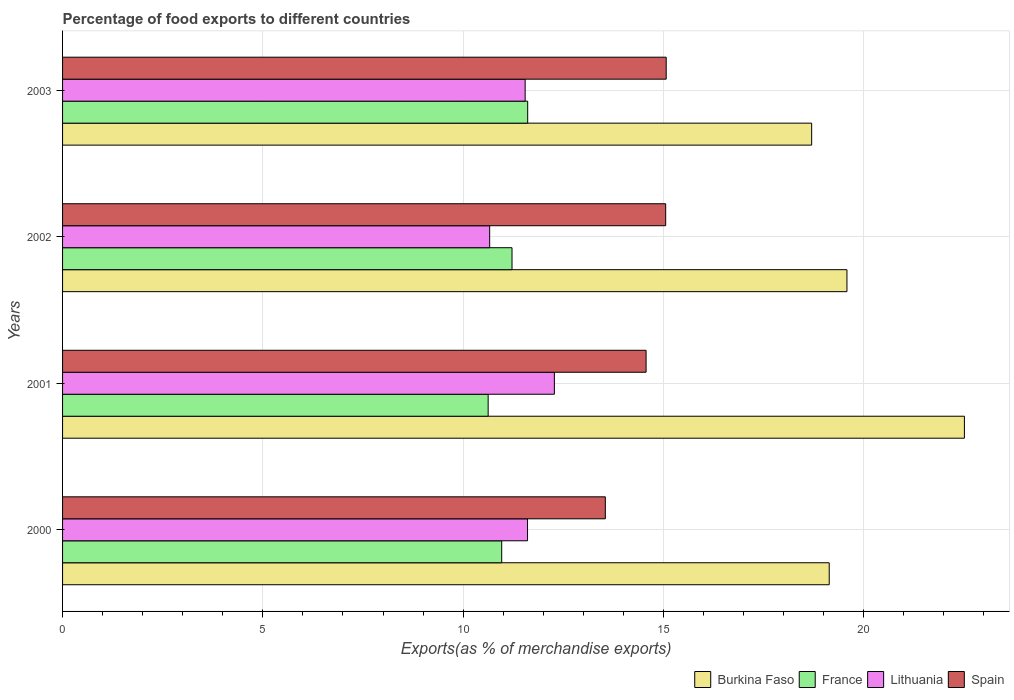How many groups of bars are there?
Offer a very short reply. 4. Are the number of bars on each tick of the Y-axis equal?
Offer a very short reply. Yes. How many bars are there on the 4th tick from the top?
Provide a succinct answer. 4. How many bars are there on the 4th tick from the bottom?
Provide a succinct answer. 4. What is the percentage of exports to different countries in Burkina Faso in 2002?
Offer a terse response. 19.58. Across all years, what is the maximum percentage of exports to different countries in Burkina Faso?
Make the answer very short. 22.51. Across all years, what is the minimum percentage of exports to different countries in Lithuania?
Provide a succinct answer. 10.66. What is the total percentage of exports to different countries in Lithuania in the graph?
Offer a very short reply. 46.09. What is the difference between the percentage of exports to different countries in France in 2000 and that in 2002?
Give a very brief answer. -0.26. What is the difference between the percentage of exports to different countries in Spain in 2000 and the percentage of exports to different countries in Burkina Faso in 2001?
Provide a short and direct response. -8.96. What is the average percentage of exports to different countries in Spain per year?
Provide a short and direct response. 14.56. In the year 2003, what is the difference between the percentage of exports to different countries in Lithuania and percentage of exports to different countries in Spain?
Offer a very short reply. -3.52. What is the ratio of the percentage of exports to different countries in Spain in 2002 to that in 2003?
Offer a terse response. 1. Is the percentage of exports to different countries in Lithuania in 2001 less than that in 2003?
Keep it short and to the point. No. What is the difference between the highest and the second highest percentage of exports to different countries in Lithuania?
Give a very brief answer. 0.67. What is the difference between the highest and the lowest percentage of exports to different countries in Burkina Faso?
Offer a terse response. 3.81. Is the sum of the percentage of exports to different countries in Burkina Faso in 2000 and 2001 greater than the maximum percentage of exports to different countries in Spain across all years?
Make the answer very short. Yes. Is it the case that in every year, the sum of the percentage of exports to different countries in Lithuania and percentage of exports to different countries in Spain is greater than the sum of percentage of exports to different countries in Burkina Faso and percentage of exports to different countries in France?
Make the answer very short. No. What does the 3rd bar from the bottom in 2002 represents?
Offer a very short reply. Lithuania. Is it the case that in every year, the sum of the percentage of exports to different countries in France and percentage of exports to different countries in Spain is greater than the percentage of exports to different countries in Burkina Faso?
Provide a succinct answer. Yes. Are all the bars in the graph horizontal?
Offer a very short reply. Yes. How many years are there in the graph?
Ensure brevity in your answer.  4. What is the difference between two consecutive major ticks on the X-axis?
Your answer should be compact. 5. Are the values on the major ticks of X-axis written in scientific E-notation?
Your answer should be compact. No. Does the graph contain any zero values?
Offer a terse response. No. Where does the legend appear in the graph?
Your response must be concise. Bottom right. What is the title of the graph?
Give a very brief answer. Percentage of food exports to different countries. Does "Eritrea" appear as one of the legend labels in the graph?
Ensure brevity in your answer.  No. What is the label or title of the X-axis?
Your answer should be very brief. Exports(as % of merchandise exports). What is the Exports(as % of merchandise exports) of Burkina Faso in 2000?
Keep it short and to the point. 19.14. What is the Exports(as % of merchandise exports) in France in 2000?
Give a very brief answer. 10.96. What is the Exports(as % of merchandise exports) in Lithuania in 2000?
Give a very brief answer. 11.61. What is the Exports(as % of merchandise exports) of Spain in 2000?
Offer a very short reply. 13.55. What is the Exports(as % of merchandise exports) in Burkina Faso in 2001?
Keep it short and to the point. 22.51. What is the Exports(as % of merchandise exports) of France in 2001?
Offer a terse response. 10.62. What is the Exports(as % of merchandise exports) in Lithuania in 2001?
Your response must be concise. 12.28. What is the Exports(as % of merchandise exports) of Spain in 2001?
Offer a terse response. 14.57. What is the Exports(as % of merchandise exports) in Burkina Faso in 2002?
Your response must be concise. 19.58. What is the Exports(as % of merchandise exports) of France in 2002?
Your answer should be very brief. 11.22. What is the Exports(as % of merchandise exports) in Lithuania in 2002?
Your answer should be very brief. 10.66. What is the Exports(as % of merchandise exports) of Spain in 2002?
Give a very brief answer. 15.06. What is the Exports(as % of merchandise exports) of Burkina Faso in 2003?
Make the answer very short. 18.7. What is the Exports(as % of merchandise exports) of France in 2003?
Offer a very short reply. 11.61. What is the Exports(as % of merchandise exports) in Lithuania in 2003?
Provide a short and direct response. 11.55. What is the Exports(as % of merchandise exports) in Spain in 2003?
Offer a very short reply. 15.07. Across all years, what is the maximum Exports(as % of merchandise exports) in Burkina Faso?
Your response must be concise. 22.51. Across all years, what is the maximum Exports(as % of merchandise exports) in France?
Ensure brevity in your answer.  11.61. Across all years, what is the maximum Exports(as % of merchandise exports) in Lithuania?
Your response must be concise. 12.28. Across all years, what is the maximum Exports(as % of merchandise exports) of Spain?
Provide a short and direct response. 15.07. Across all years, what is the minimum Exports(as % of merchandise exports) in Burkina Faso?
Offer a very short reply. 18.7. Across all years, what is the minimum Exports(as % of merchandise exports) of France?
Your response must be concise. 10.62. Across all years, what is the minimum Exports(as % of merchandise exports) of Lithuania?
Make the answer very short. 10.66. Across all years, what is the minimum Exports(as % of merchandise exports) in Spain?
Make the answer very short. 13.55. What is the total Exports(as % of merchandise exports) of Burkina Faso in the graph?
Your answer should be very brief. 79.93. What is the total Exports(as % of merchandise exports) in France in the graph?
Ensure brevity in your answer.  44.42. What is the total Exports(as % of merchandise exports) of Lithuania in the graph?
Give a very brief answer. 46.09. What is the total Exports(as % of merchandise exports) in Spain in the graph?
Your answer should be very brief. 58.24. What is the difference between the Exports(as % of merchandise exports) of Burkina Faso in 2000 and that in 2001?
Make the answer very short. -3.37. What is the difference between the Exports(as % of merchandise exports) in France in 2000 and that in 2001?
Provide a succinct answer. 0.34. What is the difference between the Exports(as % of merchandise exports) of Lithuania in 2000 and that in 2001?
Provide a short and direct response. -0.67. What is the difference between the Exports(as % of merchandise exports) in Spain in 2000 and that in 2001?
Give a very brief answer. -1.02. What is the difference between the Exports(as % of merchandise exports) of Burkina Faso in 2000 and that in 2002?
Provide a succinct answer. -0.44. What is the difference between the Exports(as % of merchandise exports) of France in 2000 and that in 2002?
Offer a very short reply. -0.26. What is the difference between the Exports(as % of merchandise exports) of Lithuania in 2000 and that in 2002?
Give a very brief answer. 0.95. What is the difference between the Exports(as % of merchandise exports) in Spain in 2000 and that in 2002?
Keep it short and to the point. -1.51. What is the difference between the Exports(as % of merchandise exports) in Burkina Faso in 2000 and that in 2003?
Keep it short and to the point. 0.44. What is the difference between the Exports(as % of merchandise exports) of France in 2000 and that in 2003?
Provide a succinct answer. -0.65. What is the difference between the Exports(as % of merchandise exports) in Lithuania in 2000 and that in 2003?
Your answer should be very brief. 0.06. What is the difference between the Exports(as % of merchandise exports) in Spain in 2000 and that in 2003?
Give a very brief answer. -1.52. What is the difference between the Exports(as % of merchandise exports) of Burkina Faso in 2001 and that in 2002?
Keep it short and to the point. 2.93. What is the difference between the Exports(as % of merchandise exports) of France in 2001 and that in 2002?
Your answer should be compact. -0.6. What is the difference between the Exports(as % of merchandise exports) of Lithuania in 2001 and that in 2002?
Your answer should be very brief. 1.62. What is the difference between the Exports(as % of merchandise exports) in Spain in 2001 and that in 2002?
Your answer should be compact. -0.49. What is the difference between the Exports(as % of merchandise exports) in Burkina Faso in 2001 and that in 2003?
Your response must be concise. 3.81. What is the difference between the Exports(as % of merchandise exports) in France in 2001 and that in 2003?
Offer a terse response. -0.99. What is the difference between the Exports(as % of merchandise exports) of Lithuania in 2001 and that in 2003?
Offer a very short reply. 0.73. What is the difference between the Exports(as % of merchandise exports) of Spain in 2001 and that in 2003?
Your answer should be very brief. -0.5. What is the difference between the Exports(as % of merchandise exports) in Burkina Faso in 2002 and that in 2003?
Offer a terse response. 0.88. What is the difference between the Exports(as % of merchandise exports) of France in 2002 and that in 2003?
Provide a succinct answer. -0.39. What is the difference between the Exports(as % of merchandise exports) in Lithuania in 2002 and that in 2003?
Keep it short and to the point. -0.89. What is the difference between the Exports(as % of merchandise exports) in Spain in 2002 and that in 2003?
Your response must be concise. -0.01. What is the difference between the Exports(as % of merchandise exports) of Burkina Faso in 2000 and the Exports(as % of merchandise exports) of France in 2001?
Provide a succinct answer. 8.51. What is the difference between the Exports(as % of merchandise exports) of Burkina Faso in 2000 and the Exports(as % of merchandise exports) of Lithuania in 2001?
Your answer should be compact. 6.86. What is the difference between the Exports(as % of merchandise exports) in Burkina Faso in 2000 and the Exports(as % of merchandise exports) in Spain in 2001?
Your answer should be compact. 4.57. What is the difference between the Exports(as % of merchandise exports) in France in 2000 and the Exports(as % of merchandise exports) in Lithuania in 2001?
Keep it short and to the point. -1.31. What is the difference between the Exports(as % of merchandise exports) in France in 2000 and the Exports(as % of merchandise exports) in Spain in 2001?
Your response must be concise. -3.6. What is the difference between the Exports(as % of merchandise exports) of Lithuania in 2000 and the Exports(as % of merchandise exports) of Spain in 2001?
Provide a succinct answer. -2.96. What is the difference between the Exports(as % of merchandise exports) of Burkina Faso in 2000 and the Exports(as % of merchandise exports) of France in 2002?
Keep it short and to the point. 7.92. What is the difference between the Exports(as % of merchandise exports) in Burkina Faso in 2000 and the Exports(as % of merchandise exports) in Lithuania in 2002?
Ensure brevity in your answer.  8.48. What is the difference between the Exports(as % of merchandise exports) in Burkina Faso in 2000 and the Exports(as % of merchandise exports) in Spain in 2002?
Your response must be concise. 4.08. What is the difference between the Exports(as % of merchandise exports) of France in 2000 and the Exports(as % of merchandise exports) of Lithuania in 2002?
Your answer should be compact. 0.3. What is the difference between the Exports(as % of merchandise exports) in France in 2000 and the Exports(as % of merchandise exports) in Spain in 2002?
Your answer should be very brief. -4.09. What is the difference between the Exports(as % of merchandise exports) in Lithuania in 2000 and the Exports(as % of merchandise exports) in Spain in 2002?
Provide a short and direct response. -3.45. What is the difference between the Exports(as % of merchandise exports) of Burkina Faso in 2000 and the Exports(as % of merchandise exports) of France in 2003?
Ensure brevity in your answer.  7.53. What is the difference between the Exports(as % of merchandise exports) in Burkina Faso in 2000 and the Exports(as % of merchandise exports) in Lithuania in 2003?
Ensure brevity in your answer.  7.59. What is the difference between the Exports(as % of merchandise exports) in Burkina Faso in 2000 and the Exports(as % of merchandise exports) in Spain in 2003?
Ensure brevity in your answer.  4.07. What is the difference between the Exports(as % of merchandise exports) in France in 2000 and the Exports(as % of merchandise exports) in Lithuania in 2003?
Provide a succinct answer. -0.59. What is the difference between the Exports(as % of merchandise exports) in France in 2000 and the Exports(as % of merchandise exports) in Spain in 2003?
Your response must be concise. -4.11. What is the difference between the Exports(as % of merchandise exports) in Lithuania in 2000 and the Exports(as % of merchandise exports) in Spain in 2003?
Your response must be concise. -3.46. What is the difference between the Exports(as % of merchandise exports) of Burkina Faso in 2001 and the Exports(as % of merchandise exports) of France in 2002?
Offer a terse response. 11.29. What is the difference between the Exports(as % of merchandise exports) in Burkina Faso in 2001 and the Exports(as % of merchandise exports) in Lithuania in 2002?
Offer a terse response. 11.85. What is the difference between the Exports(as % of merchandise exports) of Burkina Faso in 2001 and the Exports(as % of merchandise exports) of Spain in 2002?
Keep it short and to the point. 7.46. What is the difference between the Exports(as % of merchandise exports) in France in 2001 and the Exports(as % of merchandise exports) in Lithuania in 2002?
Offer a very short reply. -0.04. What is the difference between the Exports(as % of merchandise exports) in France in 2001 and the Exports(as % of merchandise exports) in Spain in 2002?
Ensure brevity in your answer.  -4.43. What is the difference between the Exports(as % of merchandise exports) of Lithuania in 2001 and the Exports(as % of merchandise exports) of Spain in 2002?
Offer a very short reply. -2.78. What is the difference between the Exports(as % of merchandise exports) in Burkina Faso in 2001 and the Exports(as % of merchandise exports) in France in 2003?
Provide a short and direct response. 10.9. What is the difference between the Exports(as % of merchandise exports) in Burkina Faso in 2001 and the Exports(as % of merchandise exports) in Lithuania in 2003?
Keep it short and to the point. 10.97. What is the difference between the Exports(as % of merchandise exports) in Burkina Faso in 2001 and the Exports(as % of merchandise exports) in Spain in 2003?
Keep it short and to the point. 7.44. What is the difference between the Exports(as % of merchandise exports) of France in 2001 and the Exports(as % of merchandise exports) of Lithuania in 2003?
Offer a very short reply. -0.92. What is the difference between the Exports(as % of merchandise exports) of France in 2001 and the Exports(as % of merchandise exports) of Spain in 2003?
Your answer should be compact. -4.44. What is the difference between the Exports(as % of merchandise exports) in Lithuania in 2001 and the Exports(as % of merchandise exports) in Spain in 2003?
Offer a terse response. -2.79. What is the difference between the Exports(as % of merchandise exports) of Burkina Faso in 2002 and the Exports(as % of merchandise exports) of France in 2003?
Provide a succinct answer. 7.97. What is the difference between the Exports(as % of merchandise exports) in Burkina Faso in 2002 and the Exports(as % of merchandise exports) in Lithuania in 2003?
Make the answer very short. 8.03. What is the difference between the Exports(as % of merchandise exports) in Burkina Faso in 2002 and the Exports(as % of merchandise exports) in Spain in 2003?
Your answer should be compact. 4.51. What is the difference between the Exports(as % of merchandise exports) in France in 2002 and the Exports(as % of merchandise exports) in Lithuania in 2003?
Offer a very short reply. -0.33. What is the difference between the Exports(as % of merchandise exports) of France in 2002 and the Exports(as % of merchandise exports) of Spain in 2003?
Your response must be concise. -3.85. What is the difference between the Exports(as % of merchandise exports) in Lithuania in 2002 and the Exports(as % of merchandise exports) in Spain in 2003?
Ensure brevity in your answer.  -4.41. What is the average Exports(as % of merchandise exports) in Burkina Faso per year?
Your answer should be very brief. 19.98. What is the average Exports(as % of merchandise exports) of France per year?
Offer a terse response. 11.1. What is the average Exports(as % of merchandise exports) in Lithuania per year?
Make the answer very short. 11.52. What is the average Exports(as % of merchandise exports) in Spain per year?
Your answer should be compact. 14.56. In the year 2000, what is the difference between the Exports(as % of merchandise exports) in Burkina Faso and Exports(as % of merchandise exports) in France?
Ensure brevity in your answer.  8.18. In the year 2000, what is the difference between the Exports(as % of merchandise exports) of Burkina Faso and Exports(as % of merchandise exports) of Lithuania?
Your answer should be very brief. 7.53. In the year 2000, what is the difference between the Exports(as % of merchandise exports) in Burkina Faso and Exports(as % of merchandise exports) in Spain?
Provide a short and direct response. 5.59. In the year 2000, what is the difference between the Exports(as % of merchandise exports) in France and Exports(as % of merchandise exports) in Lithuania?
Your answer should be compact. -0.64. In the year 2000, what is the difference between the Exports(as % of merchandise exports) of France and Exports(as % of merchandise exports) of Spain?
Your answer should be compact. -2.59. In the year 2000, what is the difference between the Exports(as % of merchandise exports) of Lithuania and Exports(as % of merchandise exports) of Spain?
Ensure brevity in your answer.  -1.94. In the year 2001, what is the difference between the Exports(as % of merchandise exports) in Burkina Faso and Exports(as % of merchandise exports) in France?
Ensure brevity in your answer.  11.89. In the year 2001, what is the difference between the Exports(as % of merchandise exports) in Burkina Faso and Exports(as % of merchandise exports) in Lithuania?
Keep it short and to the point. 10.24. In the year 2001, what is the difference between the Exports(as % of merchandise exports) of Burkina Faso and Exports(as % of merchandise exports) of Spain?
Your answer should be very brief. 7.95. In the year 2001, what is the difference between the Exports(as % of merchandise exports) of France and Exports(as % of merchandise exports) of Lithuania?
Offer a terse response. -1.65. In the year 2001, what is the difference between the Exports(as % of merchandise exports) of France and Exports(as % of merchandise exports) of Spain?
Your answer should be compact. -3.94. In the year 2001, what is the difference between the Exports(as % of merchandise exports) of Lithuania and Exports(as % of merchandise exports) of Spain?
Your answer should be compact. -2.29. In the year 2002, what is the difference between the Exports(as % of merchandise exports) in Burkina Faso and Exports(as % of merchandise exports) in France?
Provide a short and direct response. 8.36. In the year 2002, what is the difference between the Exports(as % of merchandise exports) of Burkina Faso and Exports(as % of merchandise exports) of Lithuania?
Your answer should be compact. 8.92. In the year 2002, what is the difference between the Exports(as % of merchandise exports) of Burkina Faso and Exports(as % of merchandise exports) of Spain?
Provide a short and direct response. 4.53. In the year 2002, what is the difference between the Exports(as % of merchandise exports) in France and Exports(as % of merchandise exports) in Lithuania?
Offer a very short reply. 0.56. In the year 2002, what is the difference between the Exports(as % of merchandise exports) of France and Exports(as % of merchandise exports) of Spain?
Your answer should be very brief. -3.84. In the year 2002, what is the difference between the Exports(as % of merchandise exports) of Lithuania and Exports(as % of merchandise exports) of Spain?
Keep it short and to the point. -4.39. In the year 2003, what is the difference between the Exports(as % of merchandise exports) in Burkina Faso and Exports(as % of merchandise exports) in France?
Make the answer very short. 7.09. In the year 2003, what is the difference between the Exports(as % of merchandise exports) in Burkina Faso and Exports(as % of merchandise exports) in Lithuania?
Keep it short and to the point. 7.15. In the year 2003, what is the difference between the Exports(as % of merchandise exports) of Burkina Faso and Exports(as % of merchandise exports) of Spain?
Make the answer very short. 3.63. In the year 2003, what is the difference between the Exports(as % of merchandise exports) in France and Exports(as % of merchandise exports) in Lithuania?
Give a very brief answer. 0.06. In the year 2003, what is the difference between the Exports(as % of merchandise exports) of France and Exports(as % of merchandise exports) of Spain?
Provide a succinct answer. -3.46. In the year 2003, what is the difference between the Exports(as % of merchandise exports) in Lithuania and Exports(as % of merchandise exports) in Spain?
Ensure brevity in your answer.  -3.52. What is the ratio of the Exports(as % of merchandise exports) in Burkina Faso in 2000 to that in 2001?
Your answer should be compact. 0.85. What is the ratio of the Exports(as % of merchandise exports) in France in 2000 to that in 2001?
Give a very brief answer. 1.03. What is the ratio of the Exports(as % of merchandise exports) in Lithuania in 2000 to that in 2001?
Provide a short and direct response. 0.95. What is the ratio of the Exports(as % of merchandise exports) of Spain in 2000 to that in 2001?
Your answer should be compact. 0.93. What is the ratio of the Exports(as % of merchandise exports) in Burkina Faso in 2000 to that in 2002?
Provide a short and direct response. 0.98. What is the ratio of the Exports(as % of merchandise exports) of France in 2000 to that in 2002?
Your response must be concise. 0.98. What is the ratio of the Exports(as % of merchandise exports) in Lithuania in 2000 to that in 2002?
Your answer should be compact. 1.09. What is the ratio of the Exports(as % of merchandise exports) in Spain in 2000 to that in 2002?
Keep it short and to the point. 0.9. What is the ratio of the Exports(as % of merchandise exports) of Burkina Faso in 2000 to that in 2003?
Provide a short and direct response. 1.02. What is the ratio of the Exports(as % of merchandise exports) of France in 2000 to that in 2003?
Your answer should be compact. 0.94. What is the ratio of the Exports(as % of merchandise exports) in Spain in 2000 to that in 2003?
Provide a short and direct response. 0.9. What is the ratio of the Exports(as % of merchandise exports) of Burkina Faso in 2001 to that in 2002?
Your answer should be compact. 1.15. What is the ratio of the Exports(as % of merchandise exports) in France in 2001 to that in 2002?
Offer a terse response. 0.95. What is the ratio of the Exports(as % of merchandise exports) of Lithuania in 2001 to that in 2002?
Make the answer very short. 1.15. What is the ratio of the Exports(as % of merchandise exports) in Spain in 2001 to that in 2002?
Ensure brevity in your answer.  0.97. What is the ratio of the Exports(as % of merchandise exports) in Burkina Faso in 2001 to that in 2003?
Keep it short and to the point. 1.2. What is the ratio of the Exports(as % of merchandise exports) of France in 2001 to that in 2003?
Provide a succinct answer. 0.92. What is the ratio of the Exports(as % of merchandise exports) in Lithuania in 2001 to that in 2003?
Keep it short and to the point. 1.06. What is the ratio of the Exports(as % of merchandise exports) of Spain in 2001 to that in 2003?
Make the answer very short. 0.97. What is the ratio of the Exports(as % of merchandise exports) of Burkina Faso in 2002 to that in 2003?
Provide a short and direct response. 1.05. What is the ratio of the Exports(as % of merchandise exports) in France in 2002 to that in 2003?
Ensure brevity in your answer.  0.97. What is the ratio of the Exports(as % of merchandise exports) in Lithuania in 2002 to that in 2003?
Your answer should be very brief. 0.92. What is the ratio of the Exports(as % of merchandise exports) in Spain in 2002 to that in 2003?
Provide a short and direct response. 1. What is the difference between the highest and the second highest Exports(as % of merchandise exports) of Burkina Faso?
Provide a short and direct response. 2.93. What is the difference between the highest and the second highest Exports(as % of merchandise exports) of France?
Offer a very short reply. 0.39. What is the difference between the highest and the second highest Exports(as % of merchandise exports) of Lithuania?
Give a very brief answer. 0.67. What is the difference between the highest and the second highest Exports(as % of merchandise exports) of Spain?
Give a very brief answer. 0.01. What is the difference between the highest and the lowest Exports(as % of merchandise exports) in Burkina Faso?
Offer a very short reply. 3.81. What is the difference between the highest and the lowest Exports(as % of merchandise exports) in Lithuania?
Give a very brief answer. 1.62. What is the difference between the highest and the lowest Exports(as % of merchandise exports) of Spain?
Provide a succinct answer. 1.52. 